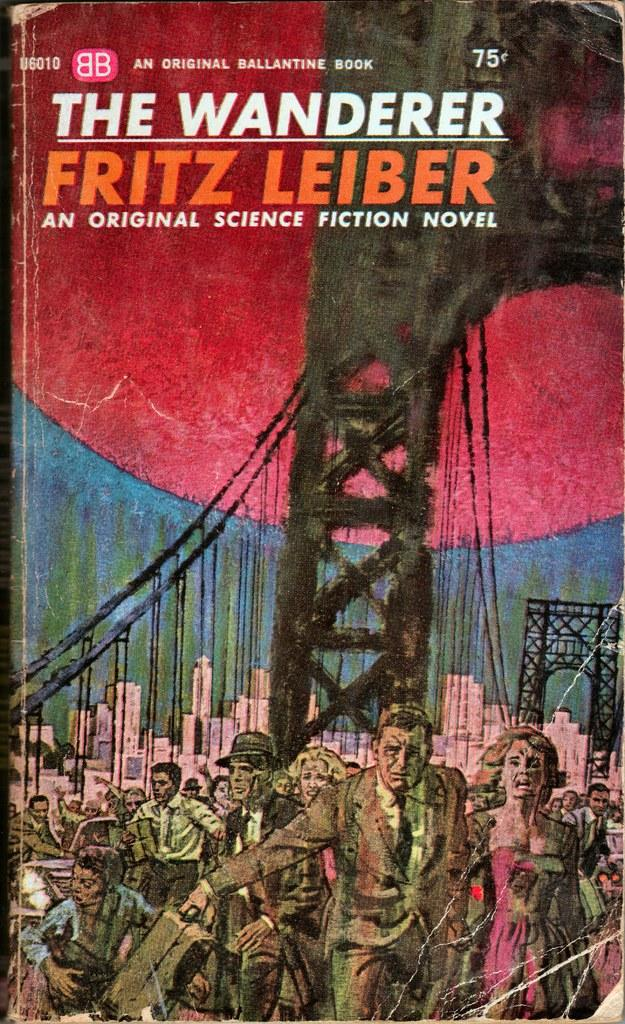<image>
Write a terse but informative summary of the picture. The book "The Wanderer" shows the golden gate bridge on the cover. 